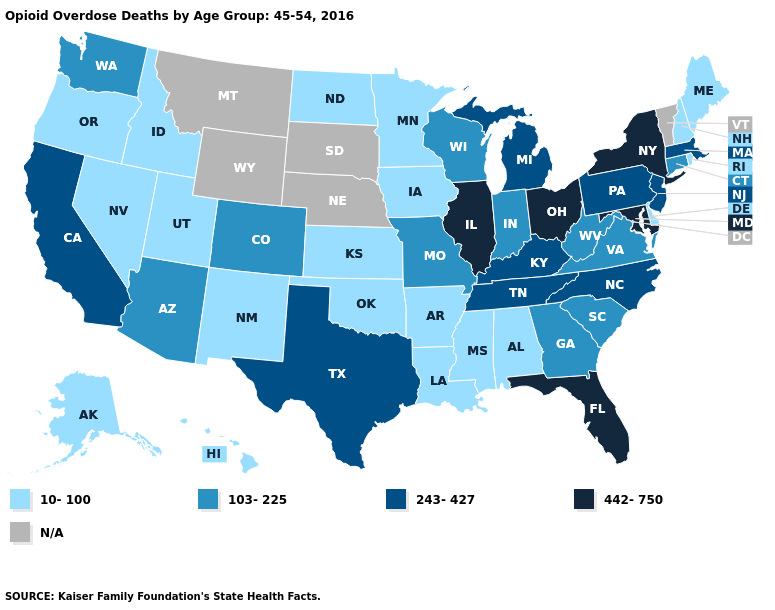Name the states that have a value in the range N/A?
Write a very short answer. Montana, Nebraska, South Dakota, Vermont, Wyoming. Name the states that have a value in the range N/A?
Give a very brief answer. Montana, Nebraska, South Dakota, Vermont, Wyoming. Name the states that have a value in the range 10-100?
Concise answer only. Alabama, Alaska, Arkansas, Delaware, Hawaii, Idaho, Iowa, Kansas, Louisiana, Maine, Minnesota, Mississippi, Nevada, New Hampshire, New Mexico, North Dakota, Oklahoma, Oregon, Rhode Island, Utah. Is the legend a continuous bar?
Short answer required. No. What is the value of Wyoming?
Give a very brief answer. N/A. Name the states that have a value in the range N/A?
Concise answer only. Montana, Nebraska, South Dakota, Vermont, Wyoming. What is the value of Nevada?
Be succinct. 10-100. Which states hav the highest value in the West?
Answer briefly. California. Name the states that have a value in the range 103-225?
Write a very short answer. Arizona, Colorado, Connecticut, Georgia, Indiana, Missouri, South Carolina, Virginia, Washington, West Virginia, Wisconsin. Which states have the lowest value in the MidWest?
Short answer required. Iowa, Kansas, Minnesota, North Dakota. Among the states that border New Jersey , does Delaware have the highest value?
Answer briefly. No. How many symbols are there in the legend?
Short answer required. 5. Name the states that have a value in the range N/A?
Keep it brief. Montana, Nebraska, South Dakota, Vermont, Wyoming. What is the value of Idaho?
Quick response, please. 10-100. 